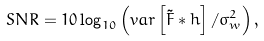Convert formula to latex. <formula><loc_0><loc_0><loc_500><loc_500>S N R = 1 0 \log _ { 1 0 } \left ( v a r \left [ \tilde { F } \ast h \right ] / \sigma _ { w } ^ { 2 } \right ) ,</formula> 